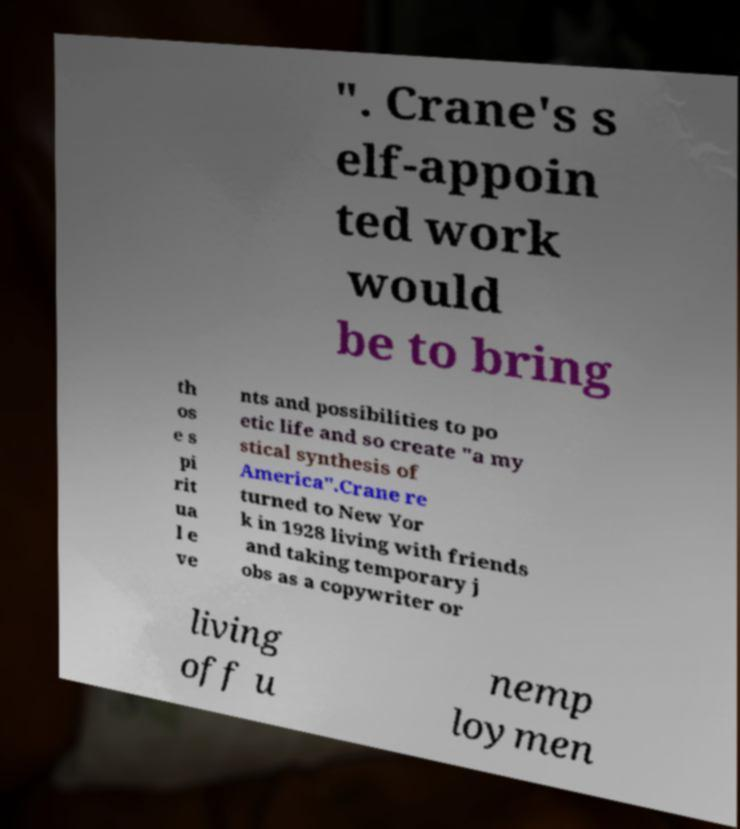Please identify and transcribe the text found in this image. ". Crane's s elf-appoin ted work would be to bring th os e s pi rit ua l e ve nts and possibilities to po etic life and so create "a my stical synthesis of America".Crane re turned to New Yor k in 1928 living with friends and taking temporary j obs as a copywriter or living off u nemp loymen 